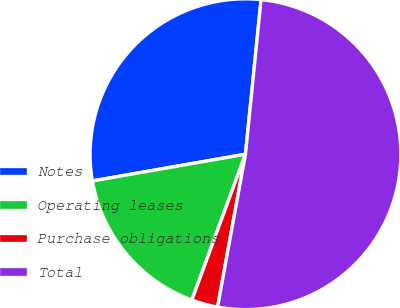<chart> <loc_0><loc_0><loc_500><loc_500><pie_chart><fcel>Notes<fcel>Operating leases<fcel>Purchase obligations<fcel>Total<nl><fcel>29.35%<fcel>16.64%<fcel>2.73%<fcel>51.27%<nl></chart> 